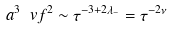Convert formula to latex. <formula><loc_0><loc_0><loc_500><loc_500>a ^ { 3 } \ v f ^ { 2 } \sim \tau ^ { - 3 + 2 \lambda _ { - } } = \tau ^ { - 2 \nu }</formula> 